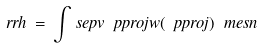Convert formula to latex. <formula><loc_0><loc_0><loc_500><loc_500>\ r r h \, = \, \int _ { \ } s e p v \ p p r o j w ( \ p p r o j ) \ m e s n</formula> 